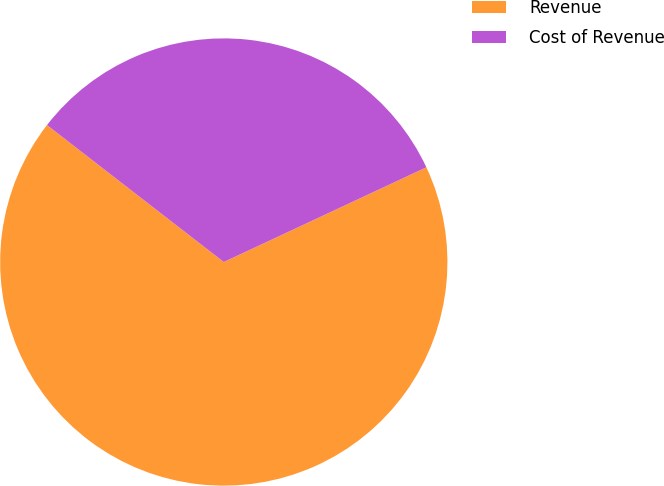Convert chart. <chart><loc_0><loc_0><loc_500><loc_500><pie_chart><fcel>Revenue<fcel>Cost of Revenue<nl><fcel>67.45%<fcel>32.55%<nl></chart> 